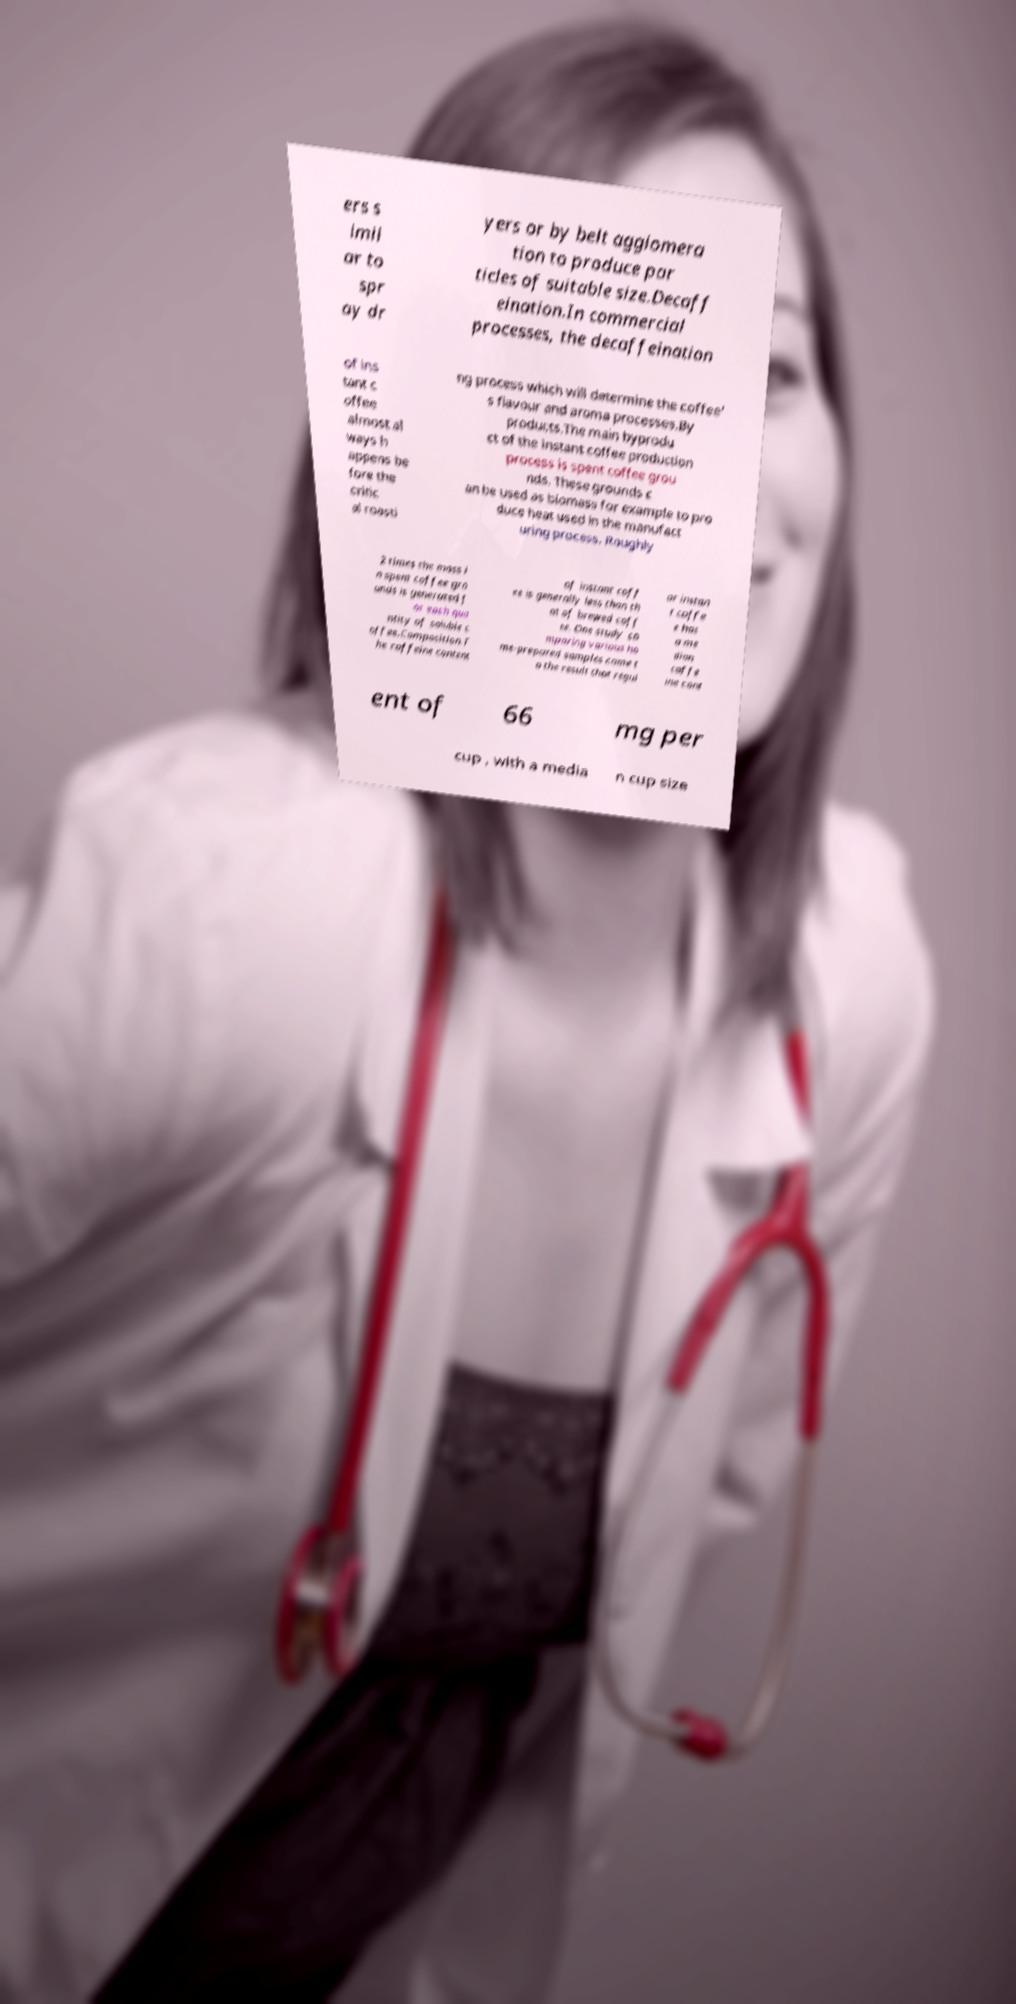There's text embedded in this image that I need extracted. Can you transcribe it verbatim? ers s imil ar to spr ay dr yers or by belt agglomera tion to produce par ticles of suitable size.Decaff eination.In commercial processes, the decaffeination of ins tant c offee almost al ways h appens be fore the critic al roasti ng process which will determine the coffee' s flavour and aroma processes.By products.The main byprodu ct of the instant coffee production process is spent coffee grou nds. These grounds c an be used as biomass for example to pro duce heat used in the manufact uring process. Roughly 2 times the mass i n spent coffee gro unds is generated f or each qua ntity of soluble c offee.Composition.T he caffeine content of instant coff ee is generally less than th at of brewed coff ee. One study co mparing various ho me-prepared samples came t o the result that regul ar instan t coffe e has a me dian caffe ine cont ent of 66 mg per cup , with a media n cup size 